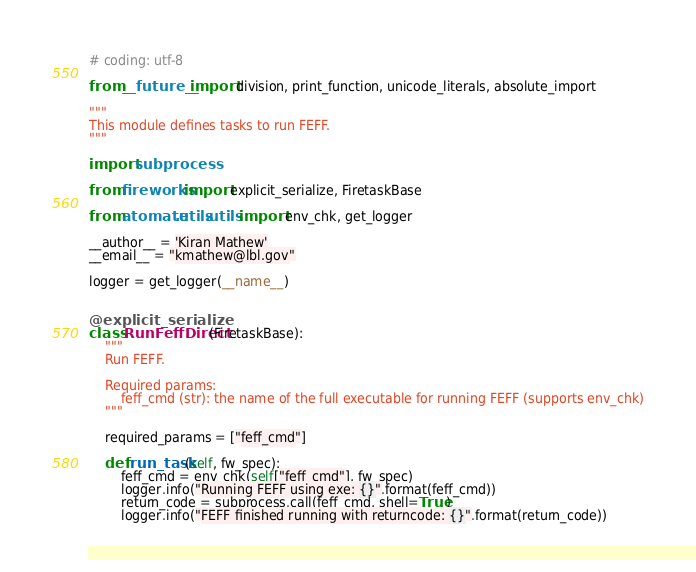<code> <loc_0><loc_0><loc_500><loc_500><_Python_># coding: utf-8

from __future__ import division, print_function, unicode_literals, absolute_import

"""
This module defines tasks to run FEFF.
"""

import subprocess

from fireworks import explicit_serialize, FiretaskBase

from atomate.utils.utils import env_chk, get_logger

__author__ = 'Kiran Mathew'
__email__ = "kmathew@lbl.gov"

logger = get_logger(__name__)


@explicit_serialize
class RunFeffDirect(FiretaskBase):
    """
    Run FEFF.

    Required params:
        feff_cmd (str): the name of the full executable for running FEFF (supports env_chk)
    """

    required_params = ["feff_cmd"]

    def run_task(self, fw_spec):
        feff_cmd = env_chk(self["feff_cmd"], fw_spec)
        logger.info("Running FEFF using exe: {}".format(feff_cmd))
        return_code = subprocess.call(feff_cmd, shell=True)
        logger.info("FEFF finished running with returncode: {}".format(return_code))
</code> 